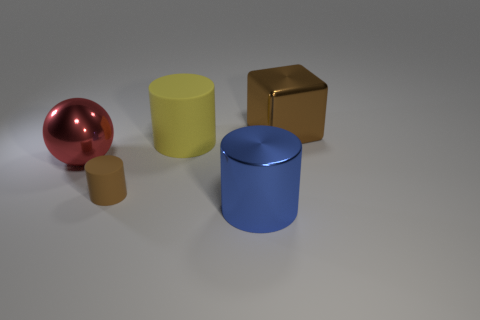Add 3 cyan cylinders. How many objects exist? 8 Subtract all cylinders. How many objects are left? 2 Subtract all large metallic spheres. Subtract all big red metallic spheres. How many objects are left? 3 Add 2 big metallic things. How many big metallic things are left? 5 Add 3 big rubber objects. How many big rubber objects exist? 4 Subtract 0 gray cylinders. How many objects are left? 5 